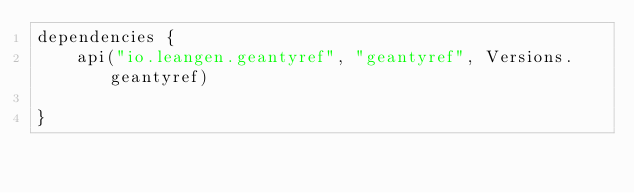Convert code to text. <code><loc_0><loc_0><loc_500><loc_500><_Kotlin_>dependencies {
    api("io.leangen.geantyref", "geantyref", Versions.geantyref)

}
</code> 